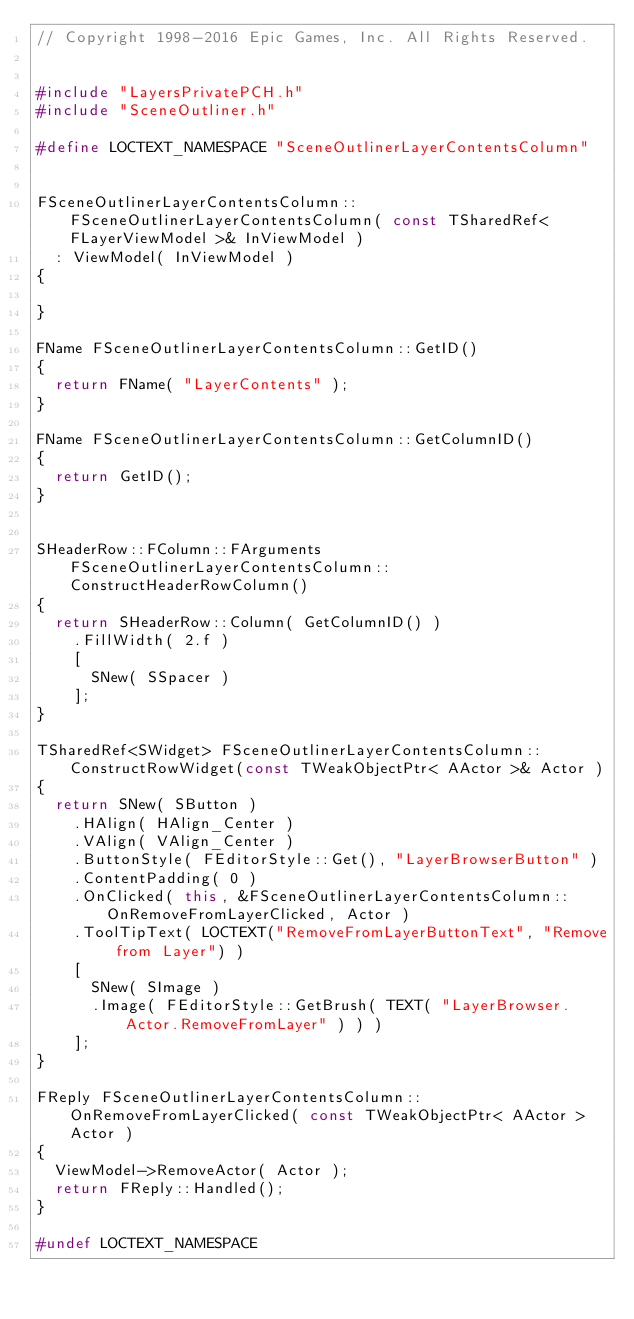<code> <loc_0><loc_0><loc_500><loc_500><_C++_>// Copyright 1998-2016 Epic Games, Inc. All Rights Reserved.


#include "LayersPrivatePCH.h"
#include "SceneOutliner.h"

#define LOCTEXT_NAMESPACE "SceneOutlinerLayerContentsColumn"


FSceneOutlinerLayerContentsColumn::FSceneOutlinerLayerContentsColumn( const TSharedRef< FLayerViewModel >& InViewModel )
	: ViewModel( InViewModel )
{

}

FName FSceneOutlinerLayerContentsColumn::GetID()
{
	return FName( "LayerContents" );
}

FName FSceneOutlinerLayerContentsColumn::GetColumnID()
{
	return GetID();
}


SHeaderRow::FColumn::FArguments FSceneOutlinerLayerContentsColumn::ConstructHeaderRowColumn()
{
	return SHeaderRow::Column( GetColumnID() )
		.FillWidth( 2.f )
		[
			SNew( SSpacer )
		];
}

TSharedRef<SWidget> FSceneOutlinerLayerContentsColumn::ConstructRowWidget(const TWeakObjectPtr< AActor >& Actor )
{
	return SNew( SButton )
		.HAlign( HAlign_Center )
		.VAlign( VAlign_Center )
		.ButtonStyle( FEditorStyle::Get(), "LayerBrowserButton" )
		.ContentPadding( 0 )
		.OnClicked( this, &FSceneOutlinerLayerContentsColumn::OnRemoveFromLayerClicked, Actor )
		.ToolTipText( LOCTEXT("RemoveFromLayerButtonText", "Remove from Layer") )
		[
			SNew( SImage )
			.Image( FEditorStyle::GetBrush( TEXT( "LayerBrowser.Actor.RemoveFromLayer" ) ) )
		];
}

FReply FSceneOutlinerLayerContentsColumn::OnRemoveFromLayerClicked( const TWeakObjectPtr< AActor > Actor )
{
	ViewModel->RemoveActor( Actor );
	return FReply::Handled();
}

#undef LOCTEXT_NAMESPACE</code> 